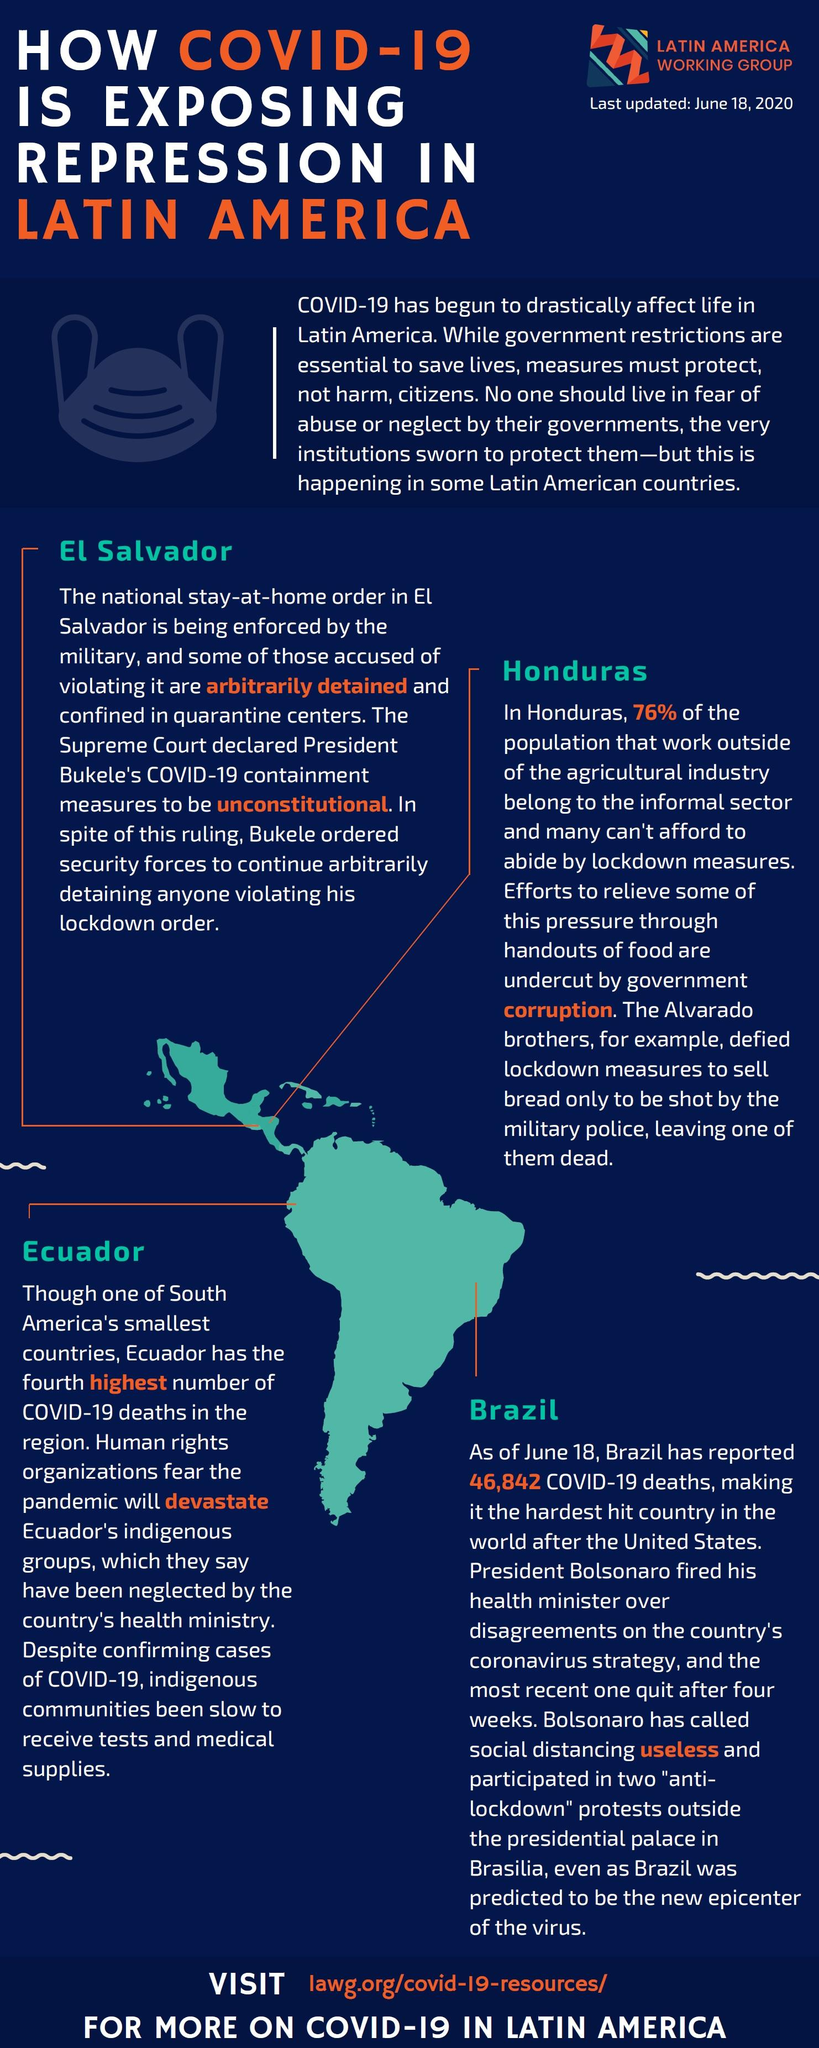Mention a couple of crucial points in this snapshot. Four Latin American countries are mentioned. 